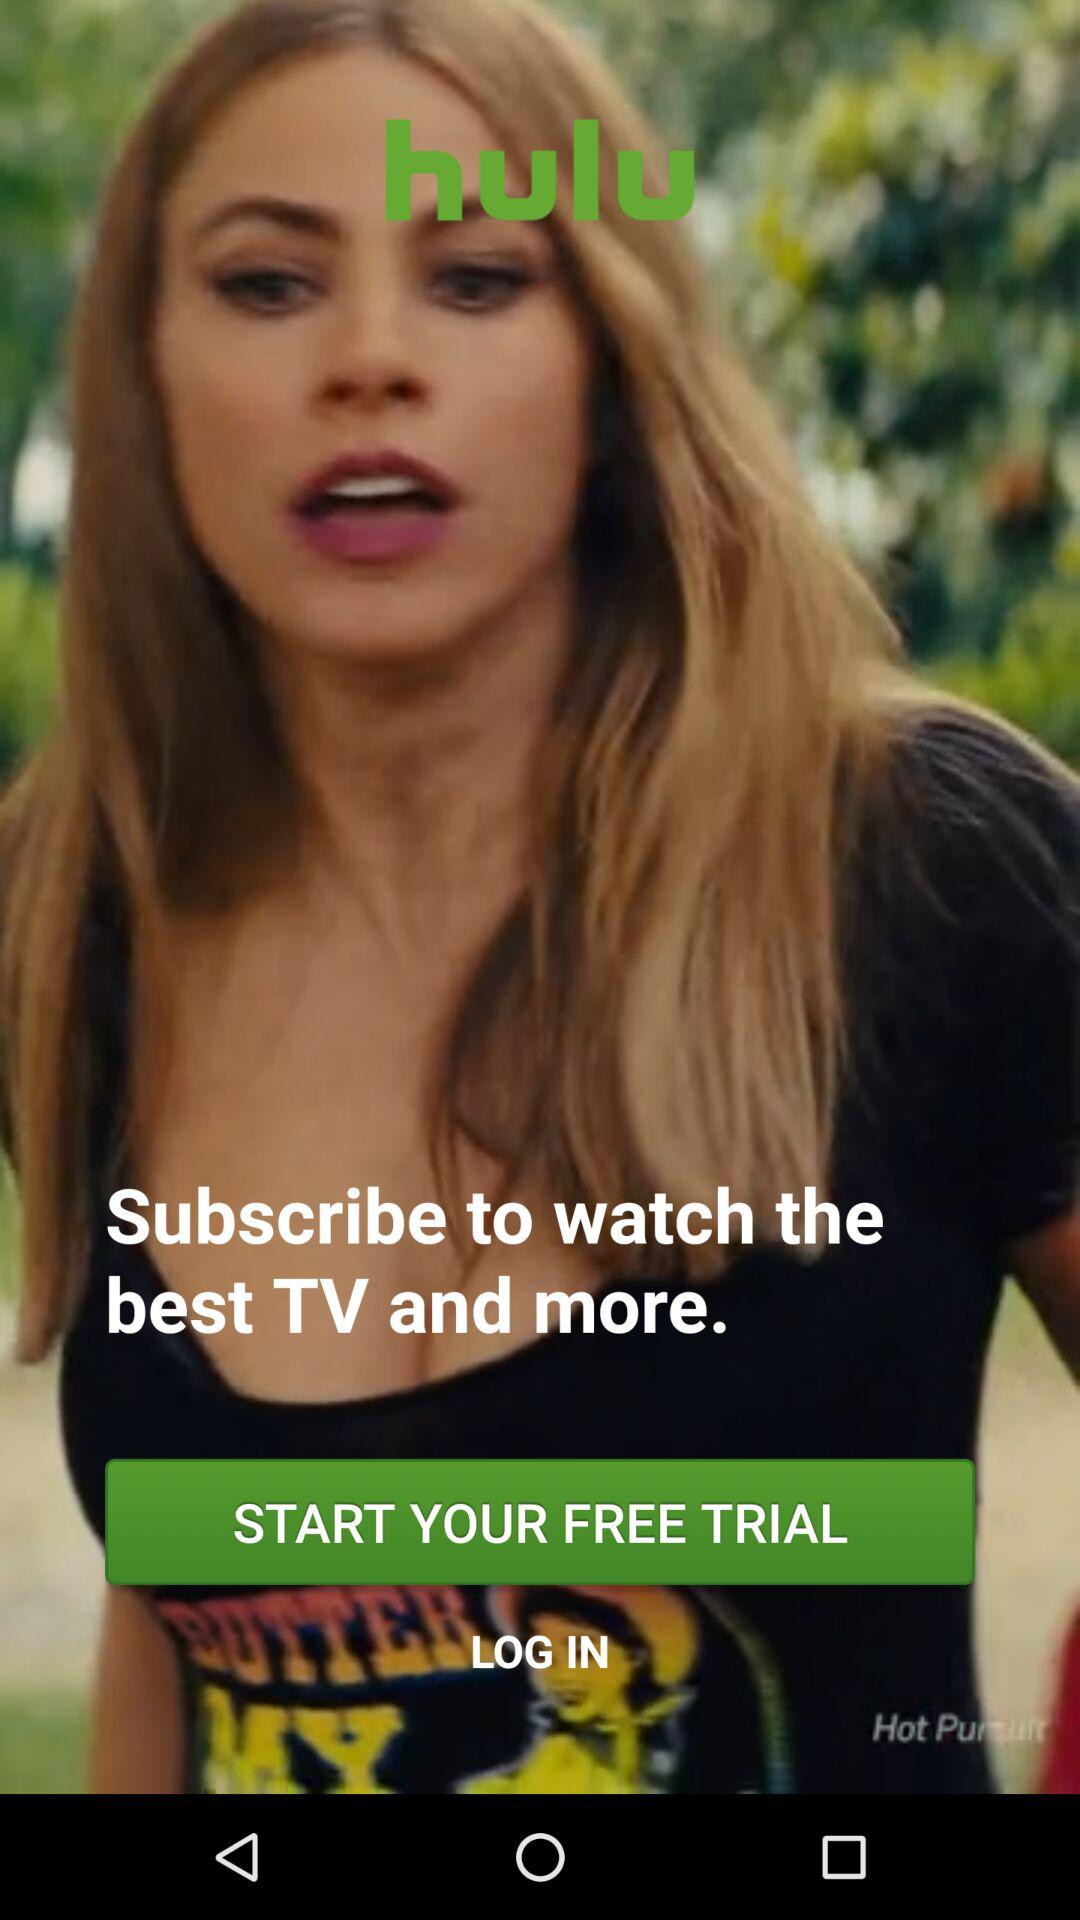What is the application name? The application name is "hulu". 